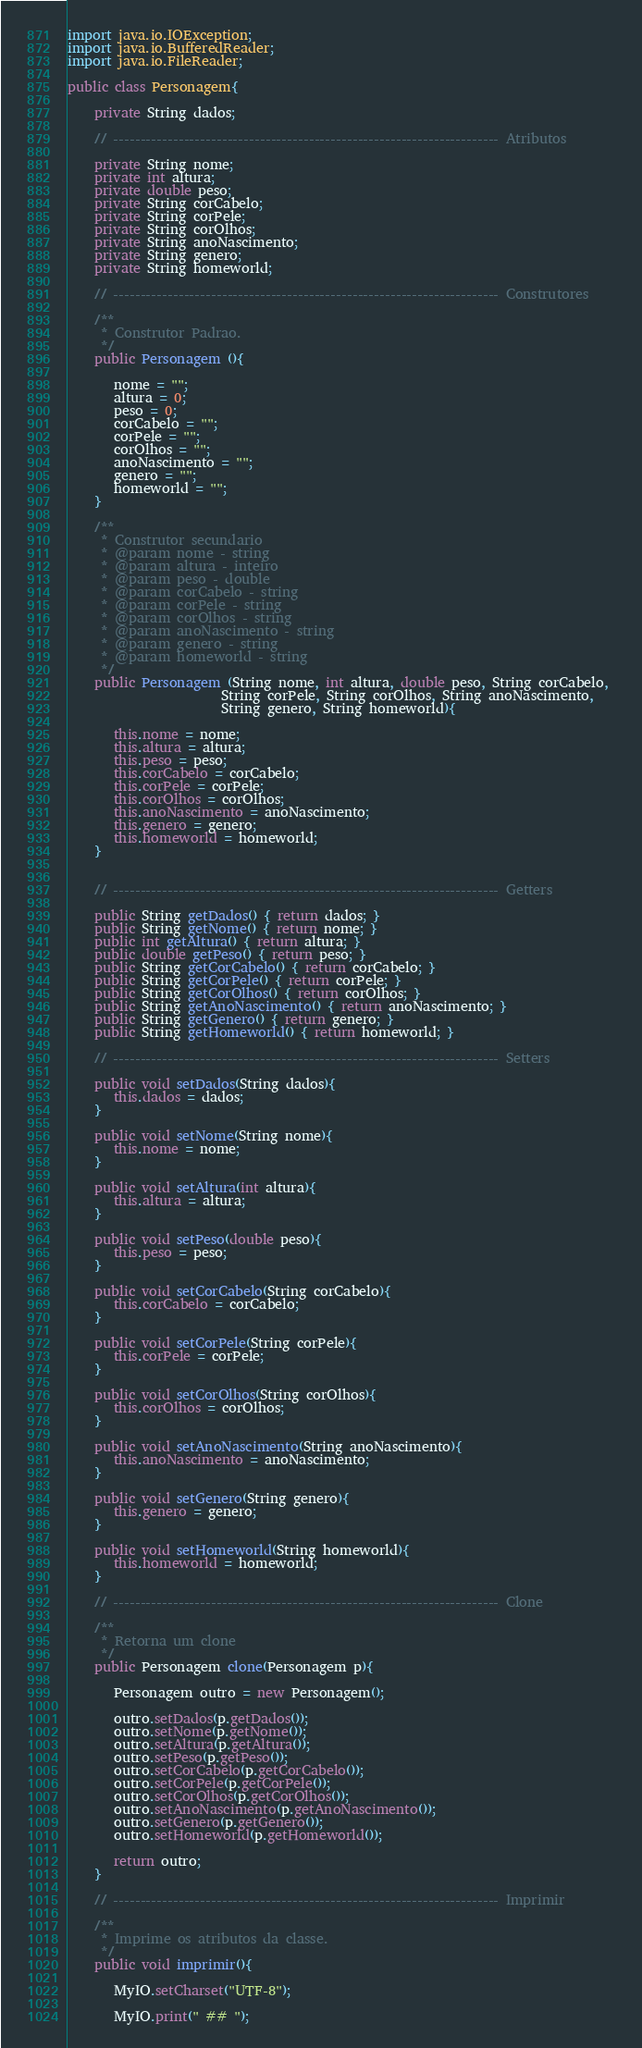Convert code to text. <code><loc_0><loc_0><loc_500><loc_500><_Java_>import java.io.IOException;
import java.io.BufferedReader;
import java.io.FileReader;

public class Personagem{

    private String dados;
 
    // ----------------------------------------------------------------------- Atributos
  
    private String nome;
    private int altura;
    private double peso;
    private String corCabelo;
    private String corPele;
    private String corOlhos;
    private String anoNascimento;
    private String genero;
    private String homeworld;
 
    // ----------------------------------------------------------------------- Construtores
 
    /**
     * Construtor Padrao.
     */
    public Personagem (){
 
       nome = "";
       altura = 0;
       peso = 0;
       corCabelo = "";
       corPele = "";
       corOlhos = "";
       anoNascimento = "";
       genero = "";
       homeworld = "";
    }
 
    /**
     * Construtor secundario
     * @param nome - string
     * @param altura - inteiro
     * @param peso - double
     * @param corCabelo - string
     * @param corPele - string
     * @param corOlhos - string
     * @param anoNascimento - string
     * @param genero - string
     * @param homeworld - string
     */
    public Personagem (String nome, int altura, double peso, String corCabelo, 
                       String corPele, String corOlhos, String anoNascimento,
                       String genero, String homeworld){
 
       this.nome = nome;
       this.altura = altura;
       this.peso = peso;
       this.corCabelo = corCabelo;
       this.corPele = corPele;
       this.corOlhos = corOlhos;
       this.anoNascimento = anoNascimento;
       this.genero = genero;
       this.homeworld = homeworld;
    }
  
 
    // ----------------------------------------------------------------------- Getters
 
    public String getDados() { return dados; }
    public String getNome() { return nome; }
    public int getAltura() { return altura; }
    public double getPeso() { return peso; }
    public String getCorCabelo() { return corCabelo; }
    public String getCorPele() { return corPele; }
    public String getCorOlhos() { return corOlhos; }
    public String getAnoNascimento() { return anoNascimento; }
    public String getGenero() { return genero; }
    public String getHomeworld() { return homeworld; }
 
    // ----------------------------------------------------------------------- Setters
  
    public void setDados(String dados){
       this.dados = dados;
    }
 
    public void setNome(String nome){
       this.nome = nome;
    }
 
    public void setAltura(int altura){
       this.altura = altura;
    }
 
    public void setPeso(double peso){
       this.peso = peso;
    }
 
    public void setCorCabelo(String corCabelo){
       this.corCabelo = corCabelo;
    }
 
    public void setCorPele(String corPele){
       this.corPele = corPele;
    }
 
    public void setCorOlhos(String corOlhos){
       this.corOlhos = corOlhos;
    }
 
    public void setAnoNascimento(String anoNascimento){
       this.anoNascimento = anoNascimento;
    }
 
    public void setGenero(String genero){
       this.genero = genero;
    }
 
    public void setHomeworld(String homeworld){
       this.homeworld = homeworld;
    }
   
    // ----------------------------------------------------------------------- Clone
 
    /**
     * Retorna um clone 
     */
    public Personagem clone(Personagem p){
 
       Personagem outro = new Personagem();
 
       outro.setDados(p.getDados());
       outro.setNome(p.getNome());
       outro.setAltura(p.getAltura());
       outro.setPeso(p.getPeso());
       outro.setCorCabelo(p.getCorCabelo());
       outro.setCorPele(p.getCorPele());
       outro.setCorOlhos(p.getCorOlhos());
       outro.setAnoNascimento(p.getAnoNascimento());
       outro.setGenero(p.getGenero());
       outro.setHomeworld(p.getHomeworld());
 
       return outro;
    }
 
    // ----------------------------------------------------------------------- Imprimir
    
    /**
     * Imprime os atributos da classe.
     */
    public void imprimir(){
      
       MyIO.setCharset("UTF-8");       
 
       MyIO.print(" ## ");</code> 